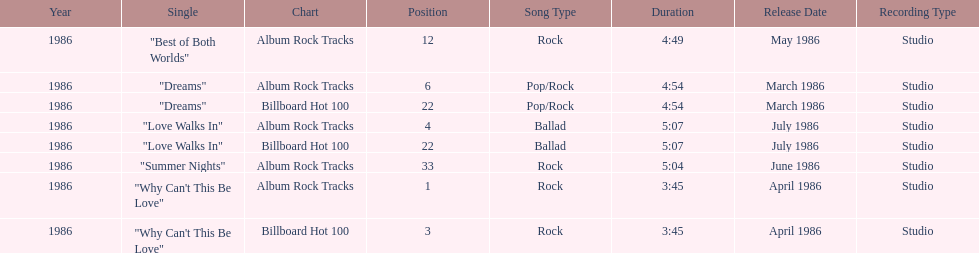Which is the most popular single on the album? Why Can't This Be Love. 